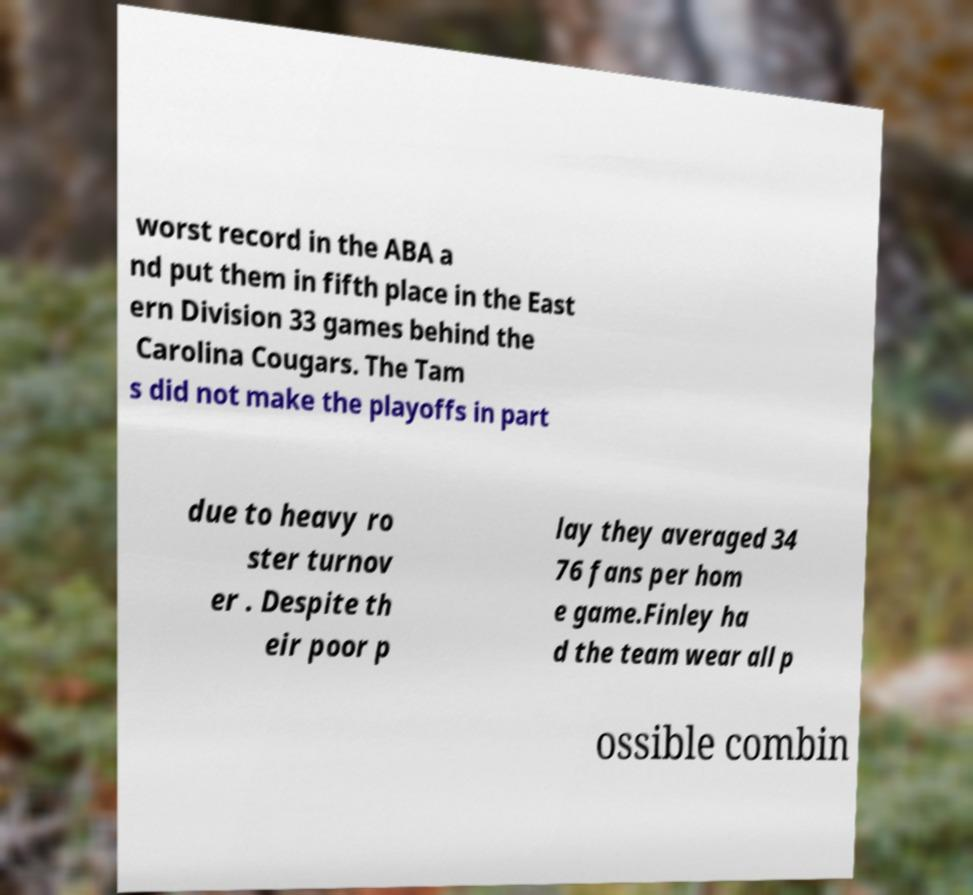Can you read and provide the text displayed in the image?This photo seems to have some interesting text. Can you extract and type it out for me? worst record in the ABA a nd put them in fifth place in the East ern Division 33 games behind the Carolina Cougars. The Tam s did not make the playoffs in part due to heavy ro ster turnov er . Despite th eir poor p lay they averaged 34 76 fans per hom e game.Finley ha d the team wear all p ossible combin 